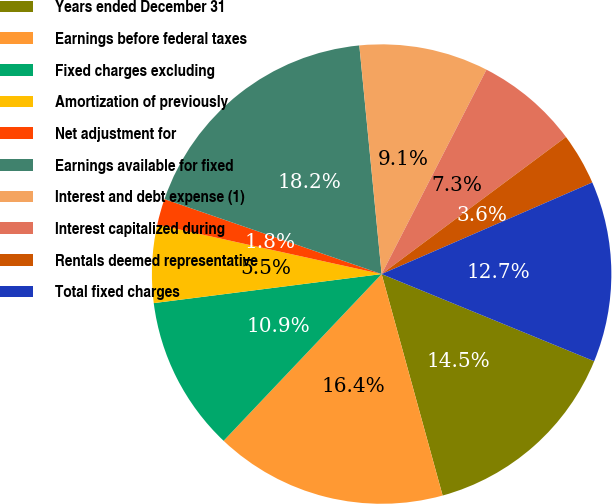Convert chart to OTSL. <chart><loc_0><loc_0><loc_500><loc_500><pie_chart><fcel>Years ended December 31<fcel>Earnings before federal taxes<fcel>Fixed charges excluding<fcel>Amortization of previously<fcel>Net adjustment for<fcel>Earnings available for fixed<fcel>Interest and debt expense (1)<fcel>Interest capitalized during<fcel>Rentals deemed representative<fcel>Total fixed charges<nl><fcel>14.53%<fcel>16.35%<fcel>10.91%<fcel>5.47%<fcel>1.84%<fcel>18.16%<fcel>9.09%<fcel>7.28%<fcel>3.65%<fcel>12.72%<nl></chart> 